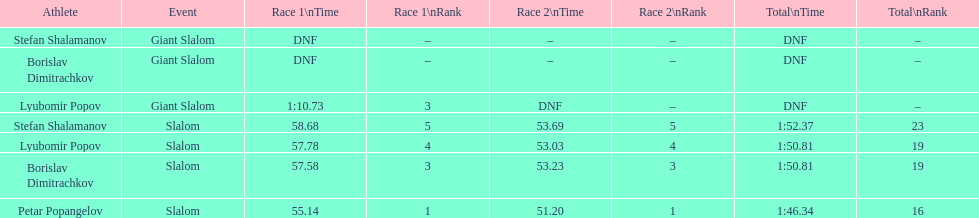Who has the highest rank? Petar Popangelov. 